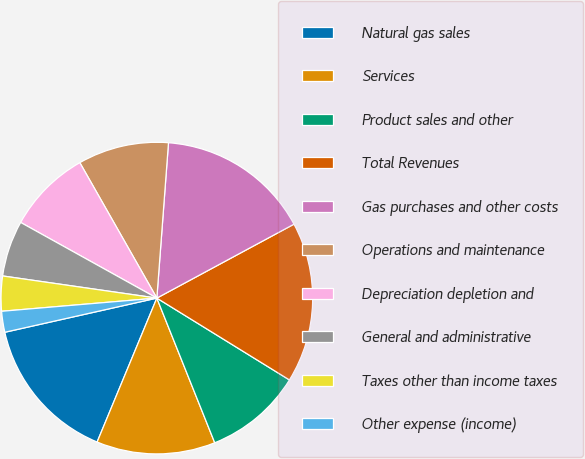Convert chart. <chart><loc_0><loc_0><loc_500><loc_500><pie_chart><fcel>Natural gas sales<fcel>Services<fcel>Product sales and other<fcel>Total Revenues<fcel>Gas purchases and other costs<fcel>Operations and maintenance<fcel>Depreciation depletion and<fcel>General and administrative<fcel>Taxes other than income taxes<fcel>Other expense (income)<nl><fcel>15.22%<fcel>12.32%<fcel>10.14%<fcel>16.67%<fcel>15.94%<fcel>9.42%<fcel>8.7%<fcel>5.8%<fcel>3.62%<fcel>2.17%<nl></chart> 